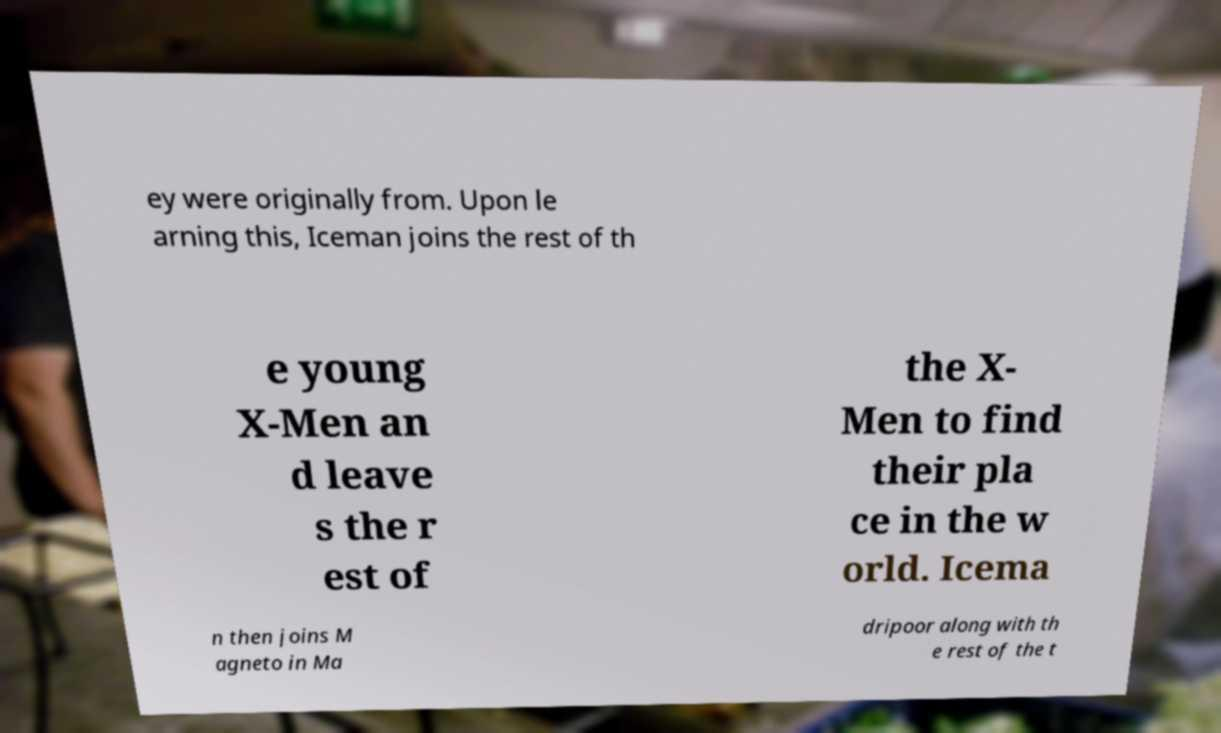Could you assist in decoding the text presented in this image and type it out clearly? ey were originally from. Upon le arning this, Iceman joins the rest of th e young X-Men an d leave s the r est of the X- Men to find their pla ce in the w orld. Icema n then joins M agneto in Ma dripoor along with th e rest of the t 